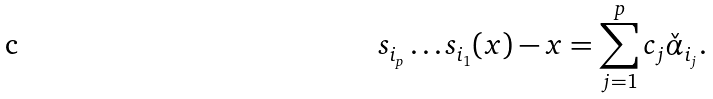<formula> <loc_0><loc_0><loc_500><loc_500>s _ { i _ { p } } \dots s _ { i _ { 1 } } ( x ) - x = \sum _ { j = 1 } ^ { p } c _ { j } \check { \alpha } _ { i _ { j } } .</formula> 